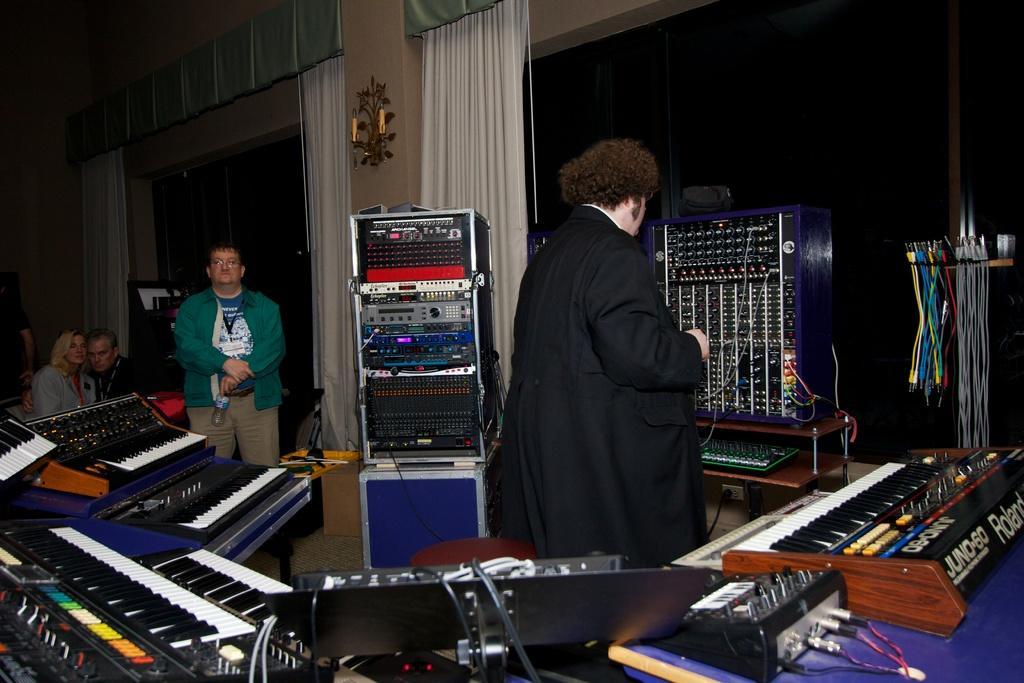Could you give a brief overview of what you see in this image? In this picture a black coat guy is standing which are piano and speakers. In the background there are few people standing. 